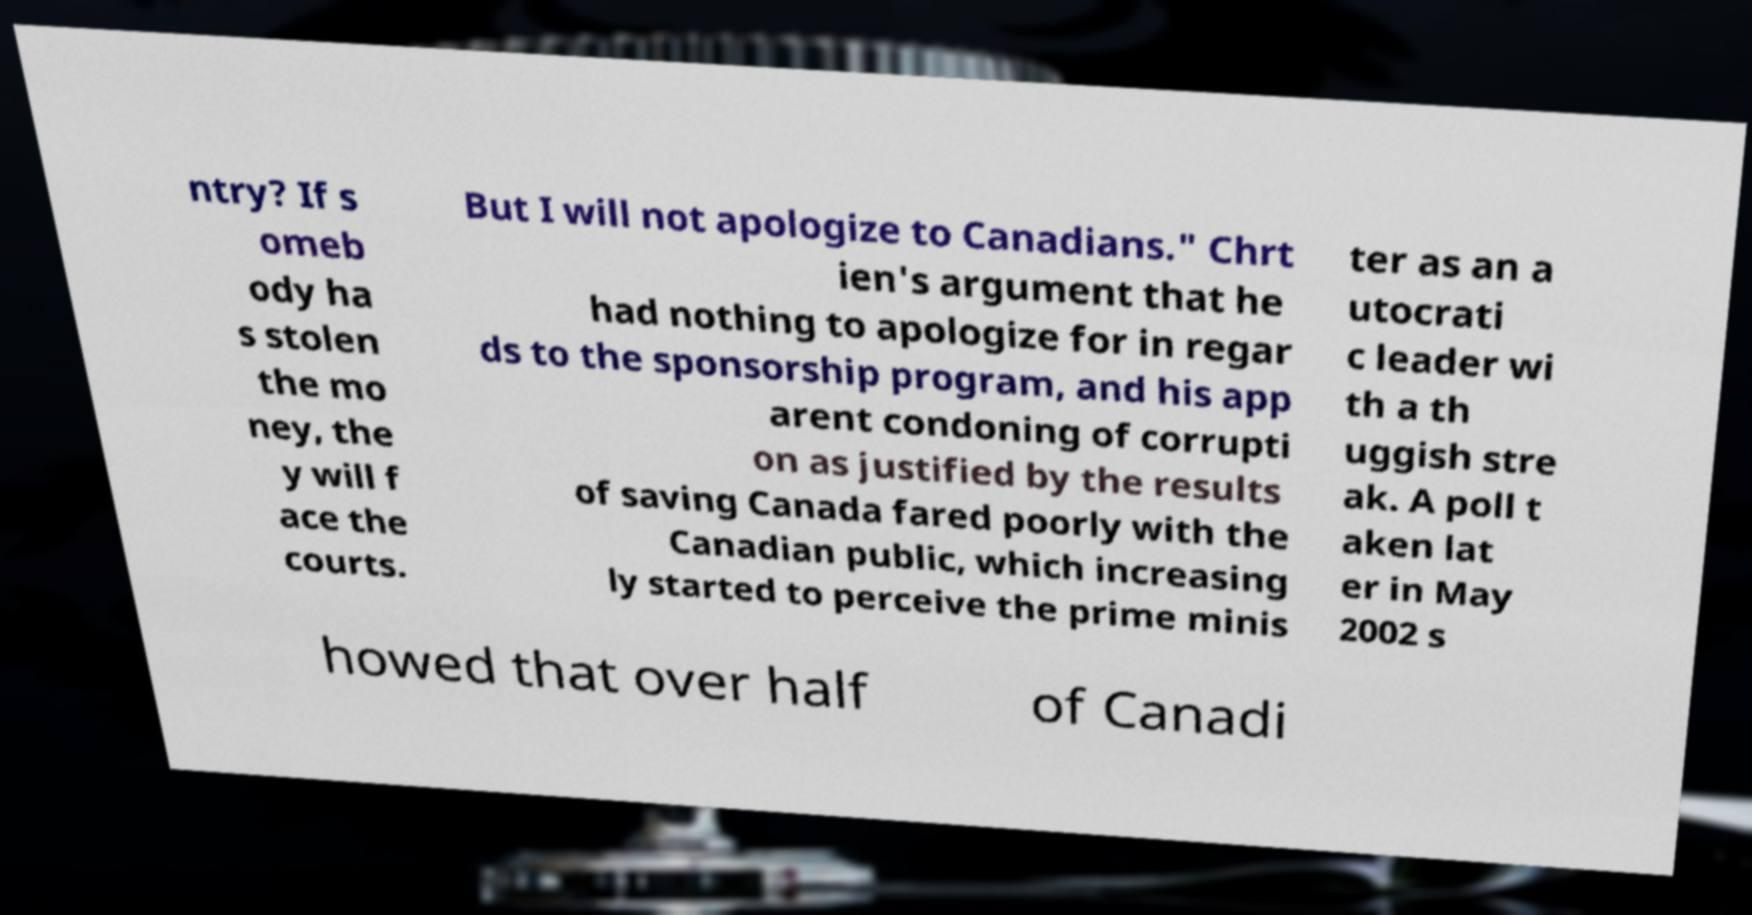Could you assist in decoding the text presented in this image and type it out clearly? ntry? If s omeb ody ha s stolen the mo ney, the y will f ace the courts. But I will not apologize to Canadians." Chrt ien's argument that he had nothing to apologize for in regar ds to the sponsorship program, and his app arent condoning of corrupti on as justified by the results of saving Canada fared poorly with the Canadian public, which increasing ly started to perceive the prime minis ter as an a utocrati c leader wi th a th uggish stre ak. A poll t aken lat er in May 2002 s howed that over half of Canadi 